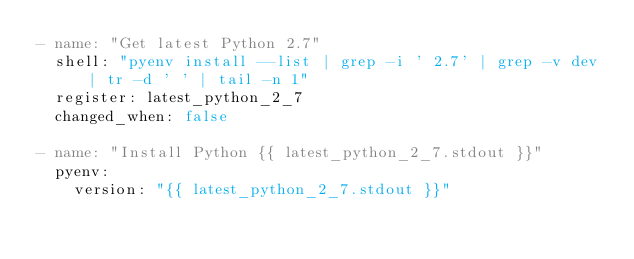<code> <loc_0><loc_0><loc_500><loc_500><_YAML_>- name: "Get latest Python 2.7"
  shell: "pyenv install --list | grep -i ' 2.7' | grep -v dev | tr -d ' ' | tail -n 1"
  register: latest_python_2_7
  changed_when: false

- name: "Install Python {{ latest_python_2_7.stdout }}"
  pyenv:
    version: "{{ latest_python_2_7.stdout }}"
</code> 